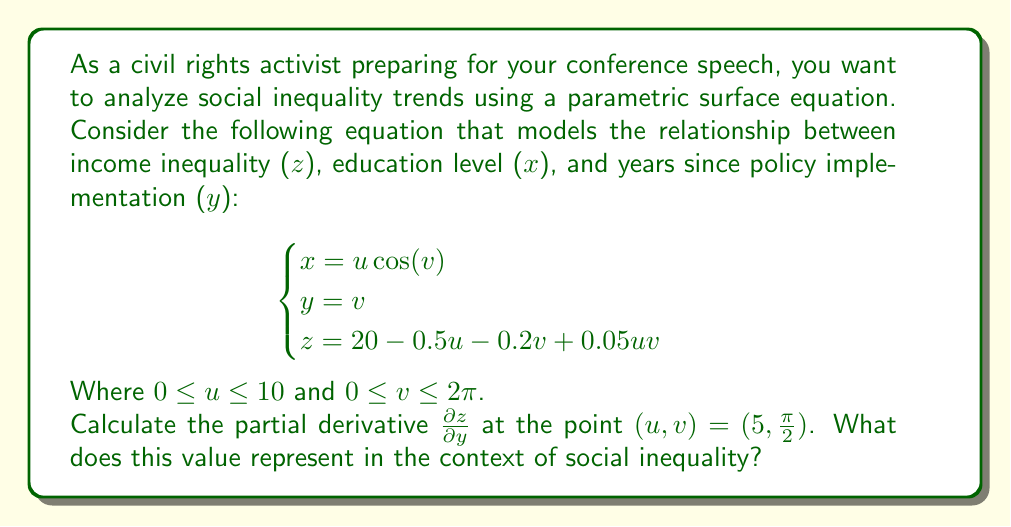Provide a solution to this math problem. To solve this problem, we need to follow these steps:

1) First, we need to express z explicitly in terms of u and v:
   $$z = 20 - 0.5u - 0.2v + 0.05uv$$

2) Now, we need to find the partial derivative of z with respect to y. However, y is given as a parameter (v), so we'll actually be finding $\frac{\partial z}{\partial v}$:
   $$\frac{\partial z}{\partial v} = -0.2 + 0.05u$$

3) We're asked to evaluate this at the point $(u, v) = (5, \frac{\pi}{2})$. Let's substitute u = 5:
   $$\frac{\partial z}{\partial v} = -0.2 + 0.05(5) = -0.2 + 0.25 = 0.05$$

4) Interpreting this result:
   The value 0.05 represents the rate of change of income inequality (z) with respect to years since policy implementation (y) at the given point. 
   
   A positive value indicates that as time passes (y increases), income inequality is slightly increasing, assuming education level (x) remains constant.

   In the context of social inequality, this suggests that the policy implemented has not been effective in reducing income inequality over time. In fact, inequality is slowly worsening despite the policy, indicating a need for reassessment or additional measures.
Answer: $\frac{\partial z}{\partial y} = 0.05$ at $(u, v) = (5, \frac{\pi}{2})$, indicating a slight increase in income inequality over time at this point. 